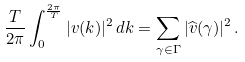Convert formula to latex. <formula><loc_0><loc_0><loc_500><loc_500>\frac { T } { 2 \pi } \int _ { 0 } ^ { \frac { 2 \pi } { T } } | v ( k ) | ^ { 2 } \, d k = \sum _ { \gamma \in \Gamma } | \widehat { v } ( \gamma ) | ^ { 2 } \, .</formula> 